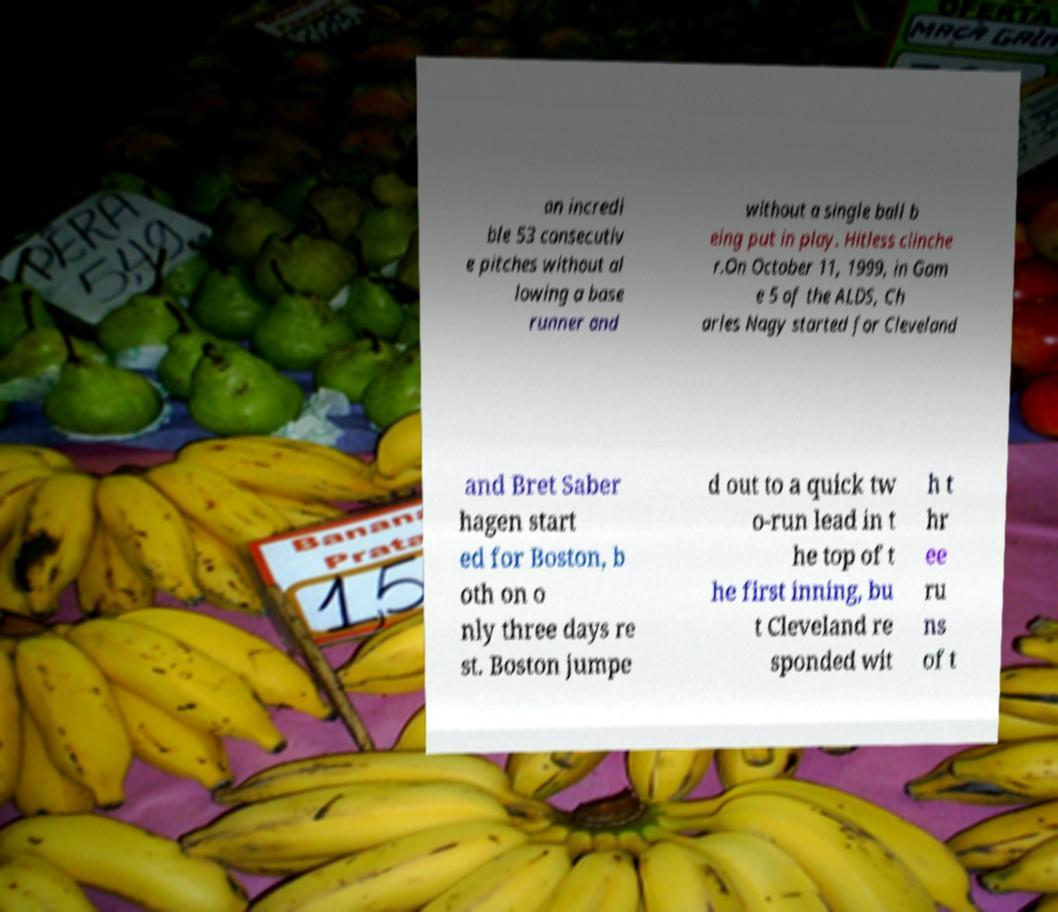Can you read and provide the text displayed in the image?This photo seems to have some interesting text. Can you extract and type it out for me? an incredi ble 53 consecutiv e pitches without al lowing a base runner and without a single ball b eing put in play. Hitless clinche r.On October 11, 1999, in Gam e 5 of the ALDS, Ch arles Nagy started for Cleveland and Bret Saber hagen start ed for Boston, b oth on o nly three days re st. Boston jumpe d out to a quick tw o-run lead in t he top of t he first inning, bu t Cleveland re sponded wit h t hr ee ru ns of t 